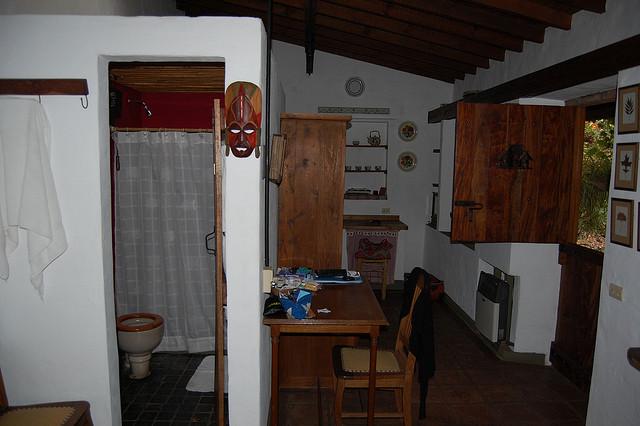What color is the walls?
Write a very short answer. White. What color are the cabinet pulls?
Quick response, please. Black. Is that a real lion on the wall?
Be succinct. No. How many chairs?
Keep it brief. 1. What part of the is this?
Keep it brief. Kitchen. What kind of room is this?
Answer briefly. Dining room. How do you get out of here?
Give a very brief answer. Door. What shapes are on  the curtains?
Answer briefly. Circles. How many chairs are there?
Answer briefly. 1. Is there any artwork visible?
Answer briefly. Yes. Is there a white toilet in this bathroom?
Be succinct. Yes. What color are the cabinets?
Give a very brief answer. Brown. What color is the towel?
Keep it brief. White. Is this likely a small apartment?
Concise answer only. Yes. Is the living space too small for the dog?
Be succinct. No. What is on the wall next to the doorway?
Answer briefly. Mask. What color is the middle towel?
Write a very short answer. White. Which room is between the living room and the kitchen?
Concise answer only. Bathroom. 